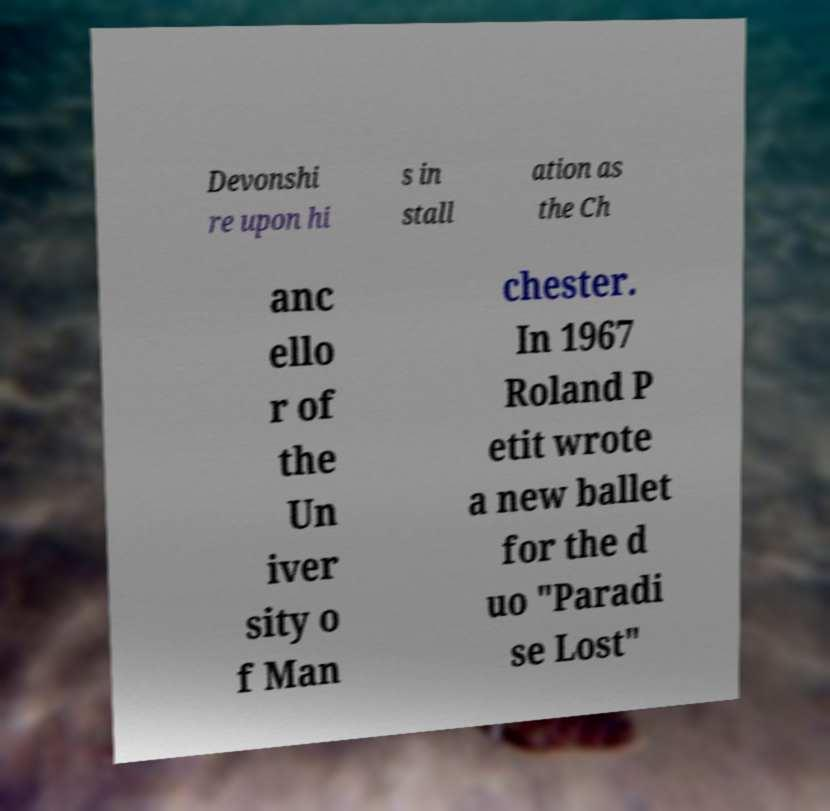Please identify and transcribe the text found in this image. Devonshi re upon hi s in stall ation as the Ch anc ello r of the Un iver sity o f Man chester. In 1967 Roland P etit wrote a new ballet for the d uo "Paradi se Lost" 